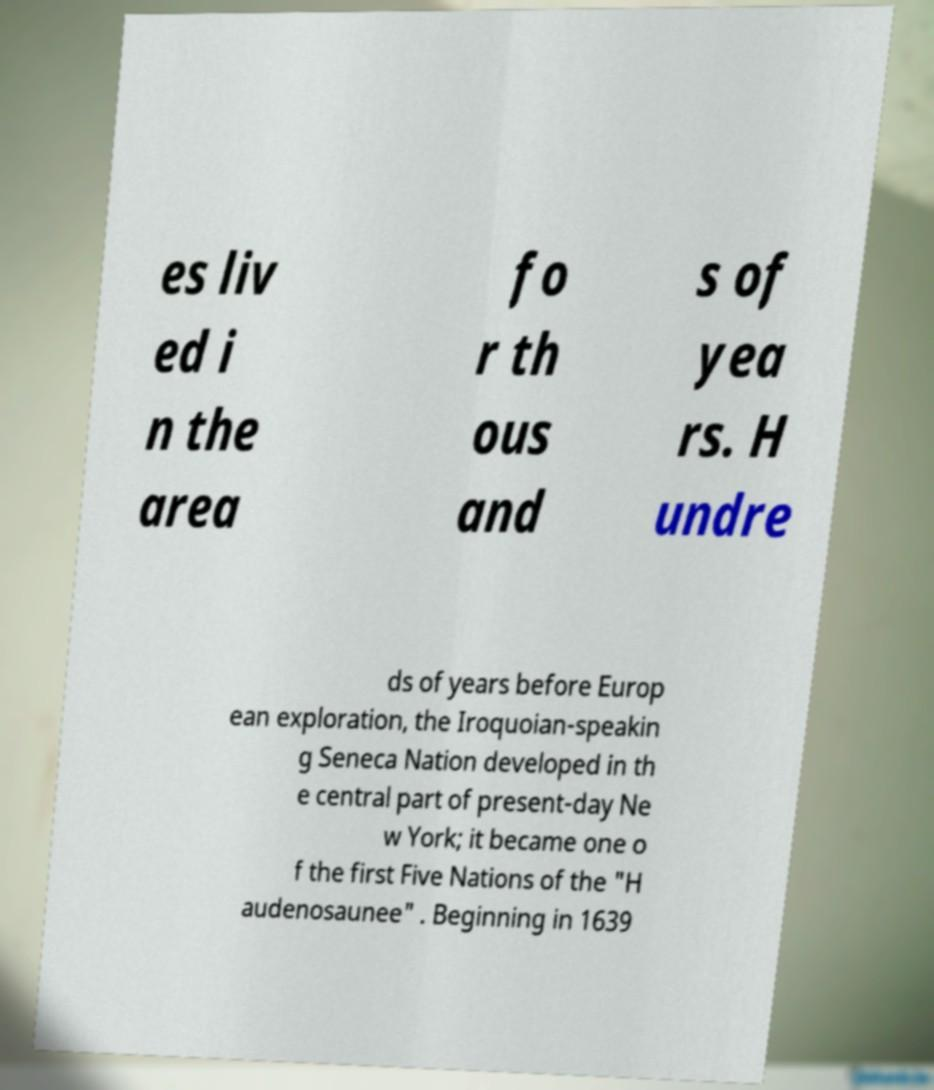Can you accurately transcribe the text from the provided image for me? es liv ed i n the area fo r th ous and s of yea rs. H undre ds of years before Europ ean exploration, the Iroquoian-speakin g Seneca Nation developed in th e central part of present-day Ne w York; it became one o f the first Five Nations of the "H audenosaunee" . Beginning in 1639 